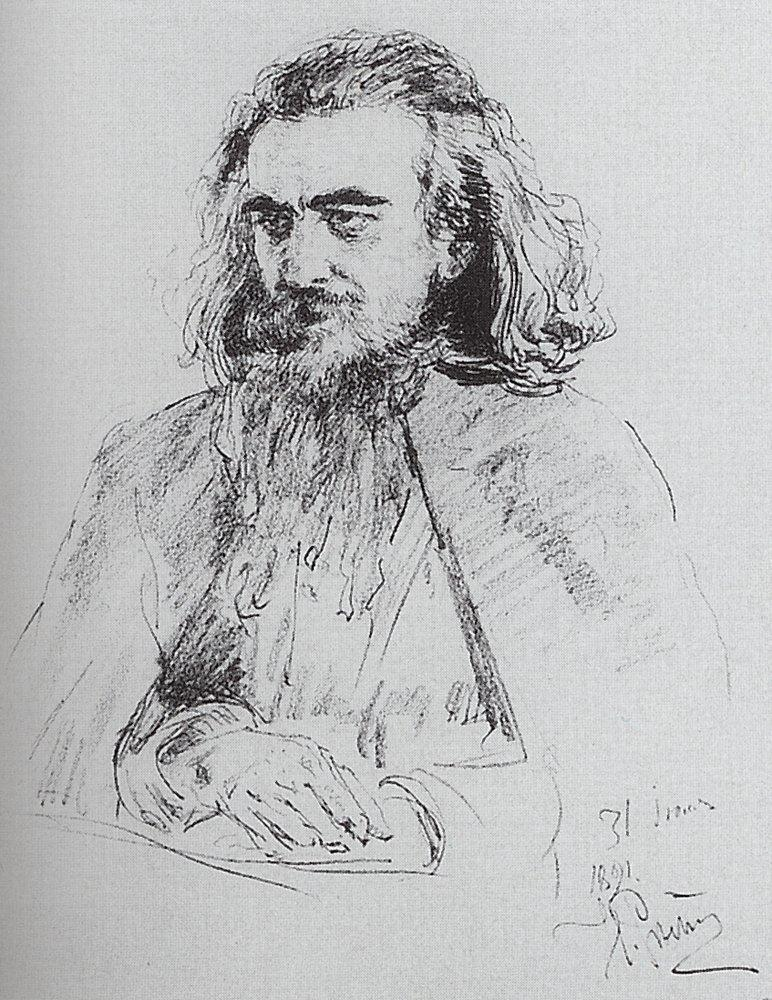Imagine a dialogue based on this sketch between this man and his mirror reflection. In a dimly lit room, the man gazes intently at his reflection in an ornate mirror. 'Who have you become?' his reflection asks, its voice echoing with a sense of timelessness. 'I am a seeker of truths,' replies the man aloud, his voice heavy with the weight of years. 'Truths I have uncovered through pain and joy, solitude and connection.' The reflection nods slowly, its eyes mirroring the depth of the man's soul. 'And what truths have you found?' it questions softly. 'That life is a series of fleeting moments, each an opportunity for growth and understanding,' the man responds. 'That our existence is like this sketch—seemingly simple yet filled with infinite details.' His reflection smiles faintly. 'Continue to seek, old friend, for the journey is far from over.' Describe how the artist might have felt while creating this sketch. The artist likely felt a deep connection to his subject while creating this sketch. Immersed in the process, he might have experienced a blend of focus and tranquility, each stroke of his pencil a meditation on the man's features and expression. The act of shading and detailing could have been both methodical and instinctive, driven by an understanding of how to convey the depth of emotion and character in his work. The date '1891' inscribed on the sketch suggests a period context, possibly influencing the artist's style and mood. Surrounded by the sounds and sights of his time, the artist's emotions could have ranged from reverence for his subject to a profound curiosity about the inner life he was capturing. This blend of technical skill and emotional resonance would result in the rich, introspective quality of the finished portrait. Imagine this man in a modern setting. What might his life and appearance be like today? In a modern setting, this man might retain his intellectual and contemplative nature. With his long hair and beard, he could be seen frequenting cafes, bookstores, or universities, perhaps as a professor, writer, or intellectual. His attire might blend classic and contemporary styles—imagine him in a tweed jacket over a casual shirt, with a pair of round spectacles to complete the look. He'd likely have a collection of worn notebooks filled with his thoughts and sketches, always carrying one in his bag. Technology would play a role in his life, but he'd be selective, using it to enhance his scholarly pursuits. Social media presence would be minimal, focusing more on platforms and communities that value deep discussion and knowledge exchange. Despite the rapid pace of modern life, his demeanor would remain calm and thoughtful, resonating with the sharegpt4v/same serene introspection captured in the original portrait. If this sketch could come to life and speak, what message might it have for the viewers? If this sketch could come to life and speak, it might convey a message of timeless wisdom and reflection. 'In every line,' it might say, 'there is a story. Look beyond the surface, and you will find the essence of not just one man, but of humanity itself. In the quiet moments, where thoughts are deep and solitude shared, we connect with our truest selves. Take time to ponder, to seek and understand, for in the journey of introspection, true wisdom is found. Cherish the quiet moments, and let them guide you to a deeper understanding of yourself and the world around you.'  What if this man was the central character in a fantasy novel? Describe his role and adventures. In a fantasy novel, this man could be a revered sage or a wise wizard, known as Eldarin the Contemplative. His adventures would take him through mystical realms and ancient forests, his wisdom sought by kings and commoners alike. Eldarin's deep understanding of ancient scrolls and his ability to communicate with ethereal beings would play a critical role in unraveling the secrets of a long-forgotten prophecy. His journey might begin in a tranquil monastery, but would soon lead him to perilous mountains and enchanted castles. Along the way, he would mentor a young protagonist, teaching them the values of patience, wisdom, and inner strength. Eldarin's quiet demeanor may hide a past filled with great trials, and as the story unfolds, his insights and knowledge would become pivotal in confronting a looming dark force threatening the balance of their world. His contemplative nature would be his greatest asset, enabling him to find solutions not through brute force, but through intelligence and profound understanding of the intricate web of the universe. 